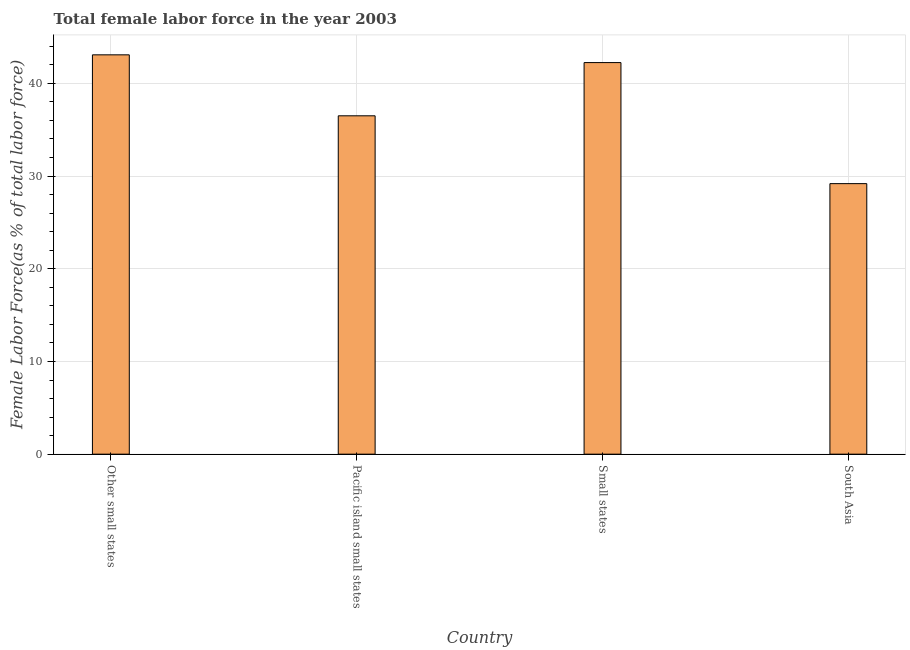What is the title of the graph?
Keep it short and to the point. Total female labor force in the year 2003. What is the label or title of the Y-axis?
Your answer should be compact. Female Labor Force(as % of total labor force). What is the total female labor force in Small states?
Keep it short and to the point. 42.24. Across all countries, what is the maximum total female labor force?
Keep it short and to the point. 43.08. Across all countries, what is the minimum total female labor force?
Provide a short and direct response. 29.18. In which country was the total female labor force maximum?
Give a very brief answer. Other small states. What is the sum of the total female labor force?
Keep it short and to the point. 151.01. What is the difference between the total female labor force in Pacific island small states and South Asia?
Keep it short and to the point. 7.32. What is the average total female labor force per country?
Provide a short and direct response. 37.75. What is the median total female labor force?
Your answer should be compact. 39.37. In how many countries, is the total female labor force greater than 38 %?
Provide a succinct answer. 2. What is the ratio of the total female labor force in Other small states to that in South Asia?
Ensure brevity in your answer.  1.48. Is the difference between the total female labor force in Pacific island small states and Small states greater than the difference between any two countries?
Ensure brevity in your answer.  No. What is the difference between the highest and the second highest total female labor force?
Your response must be concise. 0.83. Is the sum of the total female labor force in Pacific island small states and South Asia greater than the maximum total female labor force across all countries?
Make the answer very short. Yes. What is the difference between the highest and the lowest total female labor force?
Make the answer very short. 13.89. How many countries are there in the graph?
Provide a succinct answer. 4. What is the difference between two consecutive major ticks on the Y-axis?
Offer a terse response. 10. What is the Female Labor Force(as % of total labor force) in Other small states?
Give a very brief answer. 43.08. What is the Female Labor Force(as % of total labor force) of Pacific island small states?
Your answer should be very brief. 36.5. What is the Female Labor Force(as % of total labor force) of Small states?
Give a very brief answer. 42.24. What is the Female Labor Force(as % of total labor force) of South Asia?
Provide a short and direct response. 29.18. What is the difference between the Female Labor Force(as % of total labor force) in Other small states and Pacific island small states?
Your answer should be very brief. 6.58. What is the difference between the Female Labor Force(as % of total labor force) in Other small states and Small states?
Provide a succinct answer. 0.83. What is the difference between the Female Labor Force(as % of total labor force) in Other small states and South Asia?
Give a very brief answer. 13.89. What is the difference between the Female Labor Force(as % of total labor force) in Pacific island small states and Small states?
Provide a short and direct response. -5.74. What is the difference between the Female Labor Force(as % of total labor force) in Pacific island small states and South Asia?
Provide a short and direct response. 7.32. What is the difference between the Female Labor Force(as % of total labor force) in Small states and South Asia?
Ensure brevity in your answer.  13.06. What is the ratio of the Female Labor Force(as % of total labor force) in Other small states to that in Pacific island small states?
Offer a very short reply. 1.18. What is the ratio of the Female Labor Force(as % of total labor force) in Other small states to that in Small states?
Keep it short and to the point. 1.02. What is the ratio of the Female Labor Force(as % of total labor force) in Other small states to that in South Asia?
Offer a terse response. 1.48. What is the ratio of the Female Labor Force(as % of total labor force) in Pacific island small states to that in Small states?
Ensure brevity in your answer.  0.86. What is the ratio of the Female Labor Force(as % of total labor force) in Pacific island small states to that in South Asia?
Give a very brief answer. 1.25. What is the ratio of the Female Labor Force(as % of total labor force) in Small states to that in South Asia?
Provide a short and direct response. 1.45. 